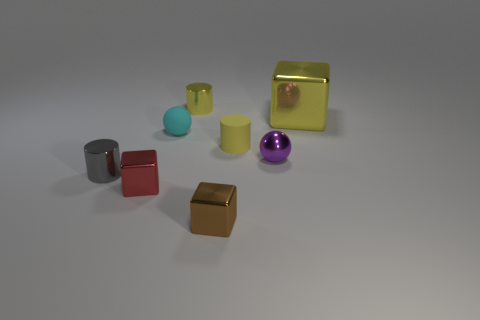Do the yellow matte cylinder and the yellow block have the same size?
Your answer should be compact. No. There is a yellow thing right of the purple shiny thing; what shape is it?
Ensure brevity in your answer.  Cube. Is there a brown metallic block of the same size as the yellow rubber thing?
Offer a terse response. Yes. There is a red thing that is the same size as the gray shiny cylinder; what is it made of?
Your response must be concise. Metal. What is the size of the cylinder that is left of the red thing?
Make the answer very short. Small. What is the size of the yellow block?
Ensure brevity in your answer.  Large. Does the yellow cube have the same size as the cylinder left of the tiny yellow shiny thing?
Offer a very short reply. No. What color is the small metallic cylinder that is to the right of the sphere on the left side of the yellow matte cylinder?
Your response must be concise. Yellow. Are there an equal number of metal cylinders on the right side of the small red cube and large objects in front of the tiny rubber cylinder?
Your answer should be very brief. No. Does the yellow cylinder that is in front of the large shiny object have the same material as the tiny red object?
Offer a terse response. No. 